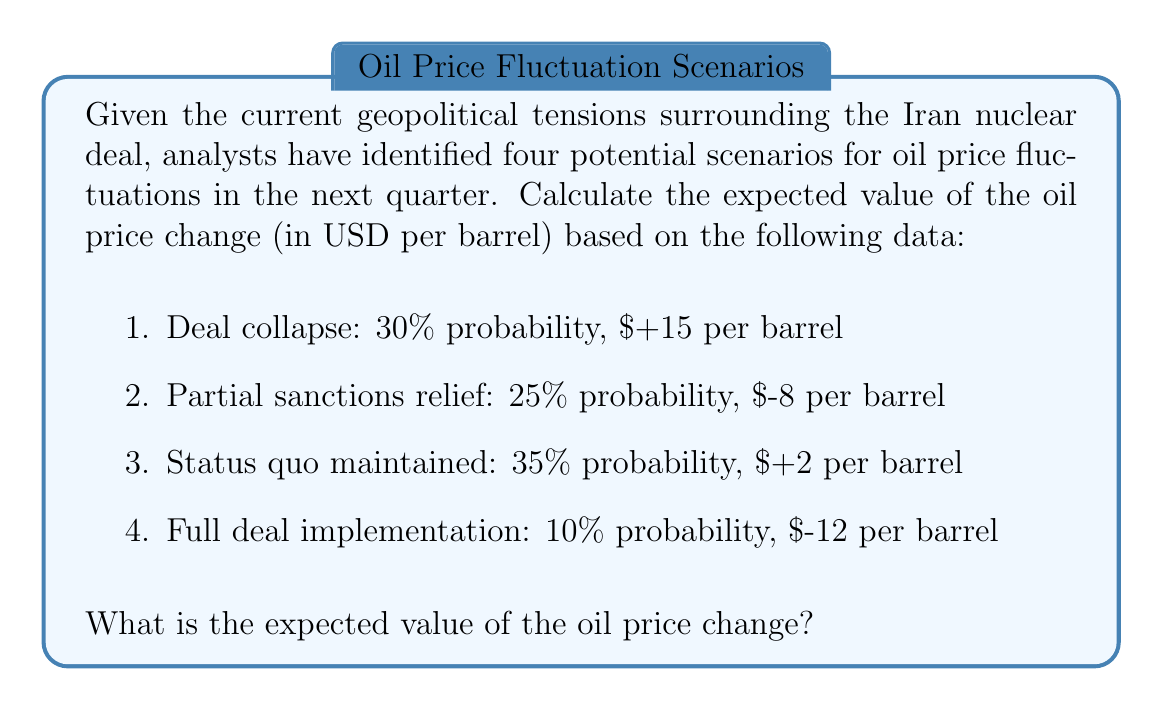Help me with this question. To calculate the expected value, we need to multiply each possible outcome by its probability and then sum these products. Let's break it down step-by-step:

1. Deal collapse:
   Probability = 30% = 0.30
   Price change = $+15
   $E_1 = 0.30 \times 15 = 4.5$

2. Partial sanctions relief:
   Probability = 25% = 0.25
   Price change = $-8
   $E_2 = 0.25 \times (-8) = -2$

3. Status quo maintained:
   Probability = 35% = 0.35
   Price change = $+2
   $E_3 = 0.35 \times 2 = 0.7$

4. Full deal implementation:
   Probability = 10% = 0.10
   Price change = $-12
   $E_4 = 0.10 \times (-12) = -1.2$

Now, we sum all these expected values:

$$E_{total} = E_1 + E_2 + E_3 + E_4$$
$$E_{total} = 4.5 + (-2) + 0.7 + (-1.2)$$
$$E_{total} = 2$$

Therefore, the expected value of the oil price change is $2 per barrel.
Answer: $2 per barrel 